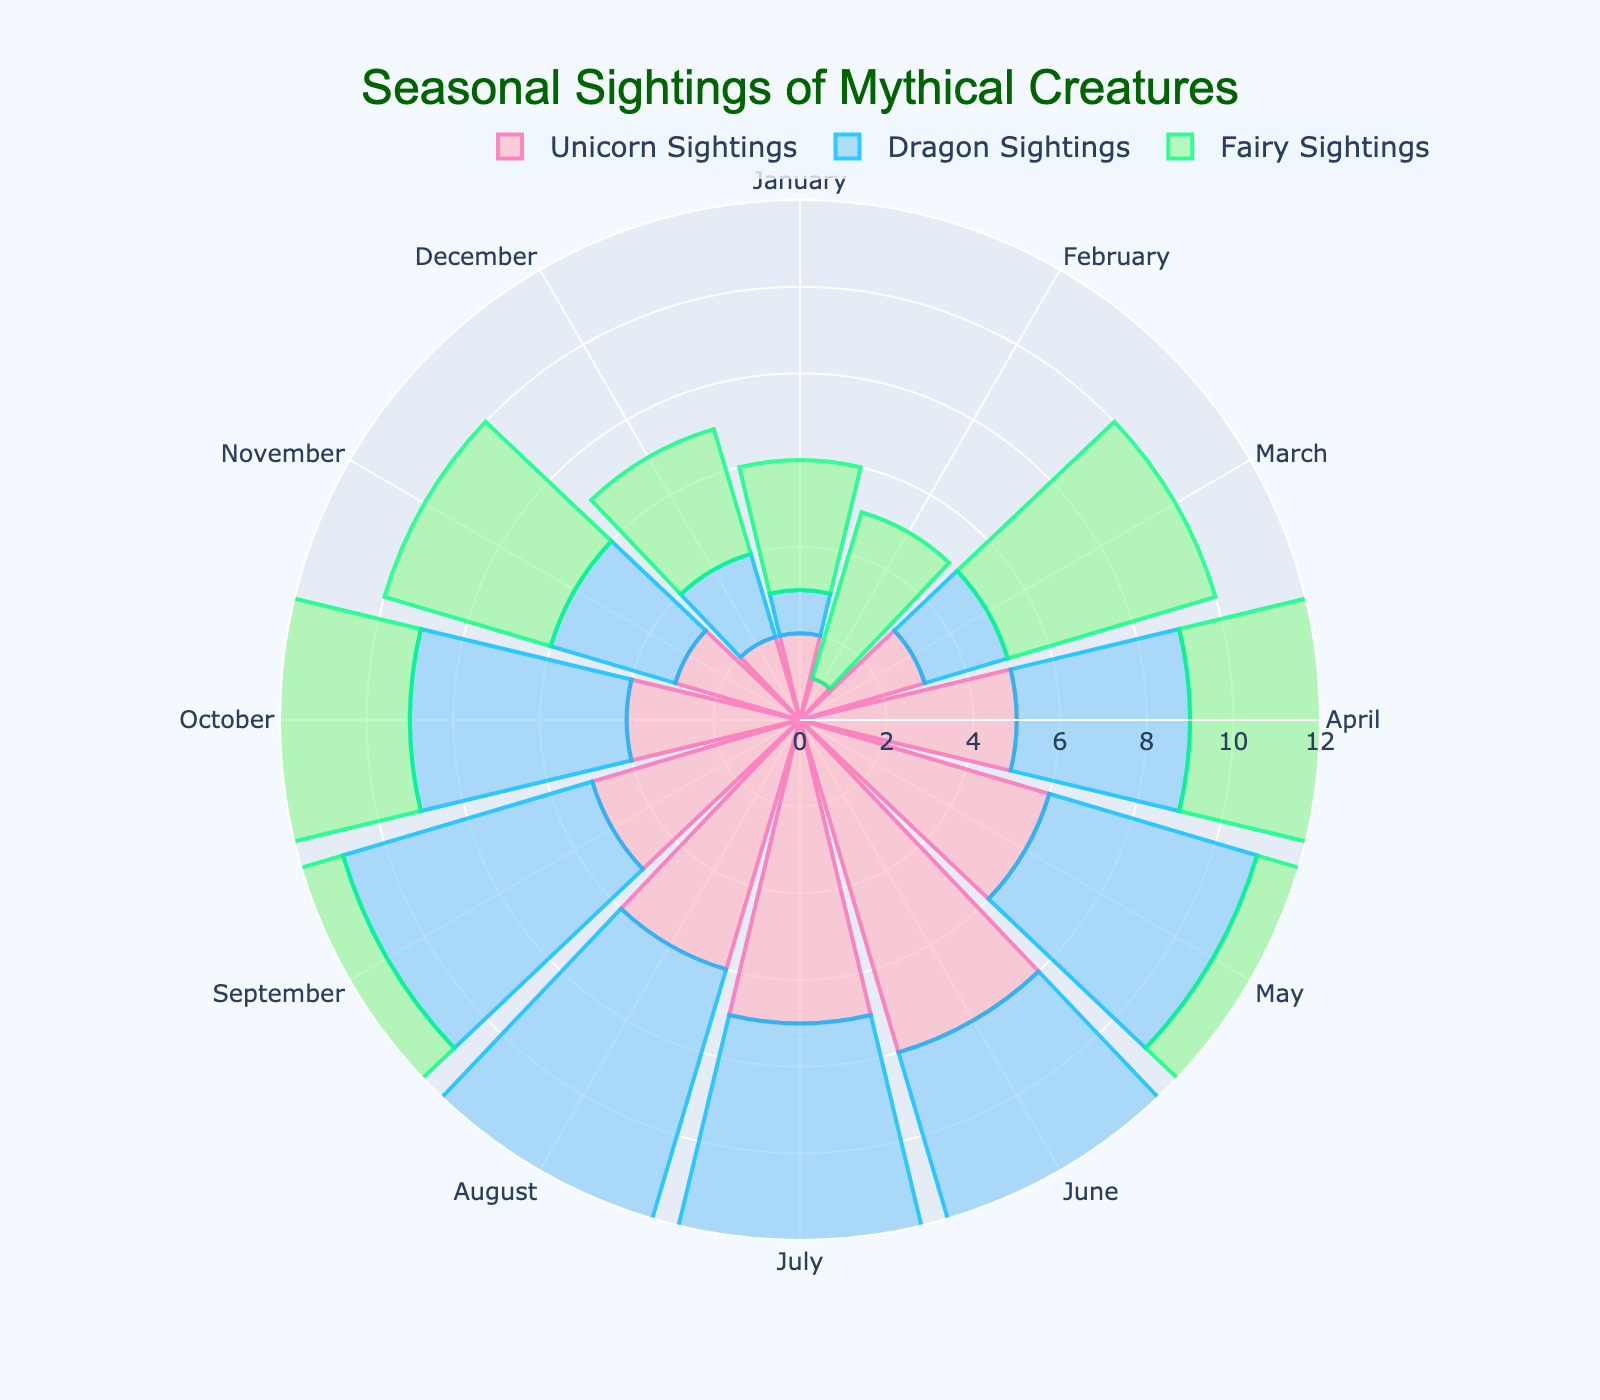Which month has the highest number of Fairy Sightings? Observe the length of the bars for Fairy Sightings across all months. The bar for Fairy Sightings in July is the longest.
Answer: July How many more Dragon Sightings are there in July compared to February? Look at the Dragon Sightings bars for July and February. The July bar has 9 sightings and February has 0. Calculate 9 - 0.
Answer: 9 Which creature has the highest total sightings throughout the year? Sum the sightings for each creature across all months: Unicorns (52), Dragons (52), Fairies (73). Fairies have the highest total.
Answer: Fairies In which month do Unicorn Sightings peak? Identify the month with the longest bar for Unicorn Sightings. The month with the longest bar is June.
Answer: June Compare the shortest Dragon Sighting month with the shortest Unicorn Sighting month. Are they the same? Look for the shortest bars in both categories. The shortest Dragon Sighting month is February (0), and the shortest Unicorn Sighting month is also February (1).
Answer: No What is the average number of Unicorn Sightings from January to June? The sightings from January to June are: 2, 1, 3, 5, 6, 8. The sum is 25. The average is 25/6.
Answer: 4.17 Which month has the least variability in sightings across all three creatures? The variability can be evaluated by the closeness of the bars' lengths. February has the closest lengths for the three creatures: Unicorn (1), Dragon (0), Fairy (4).
Answer: February How many months have more than 7 Fairy Sightings? Count the bars with lengths greater than 7 for Fairies. They are in the months May, June, and July, totaling three months.
Answer: 3 In which months are Dragon Sightings more than Unicorn Sightings but fewer than Fairy Sightings? Compare the bars for Dragon Sightings with the other two groups for each month. July (9 Dragons, 7 Unicorns, 10 Fairies), August (8 Dragons, 6 Unicorns, 8 Fairies), and September (6 Dragons, 5 Unicorns, 7 Fairies). These are the valid months.
Answer: July, August, September 